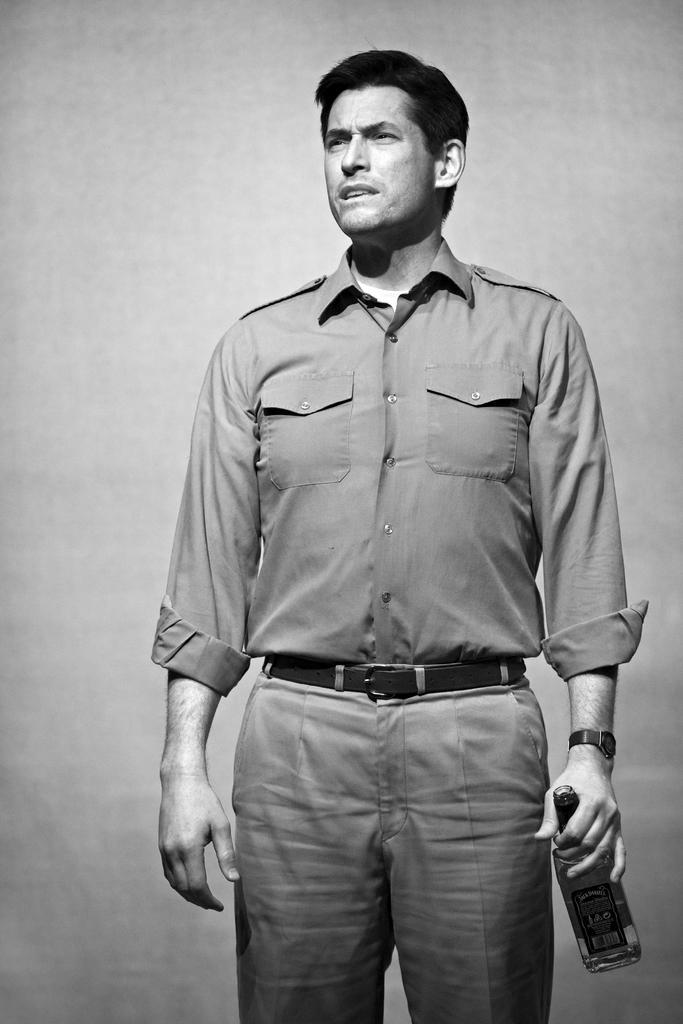Please provide a concise description of this image. In this picture we see a man holding a bottle in his right hand and looking at someone. 